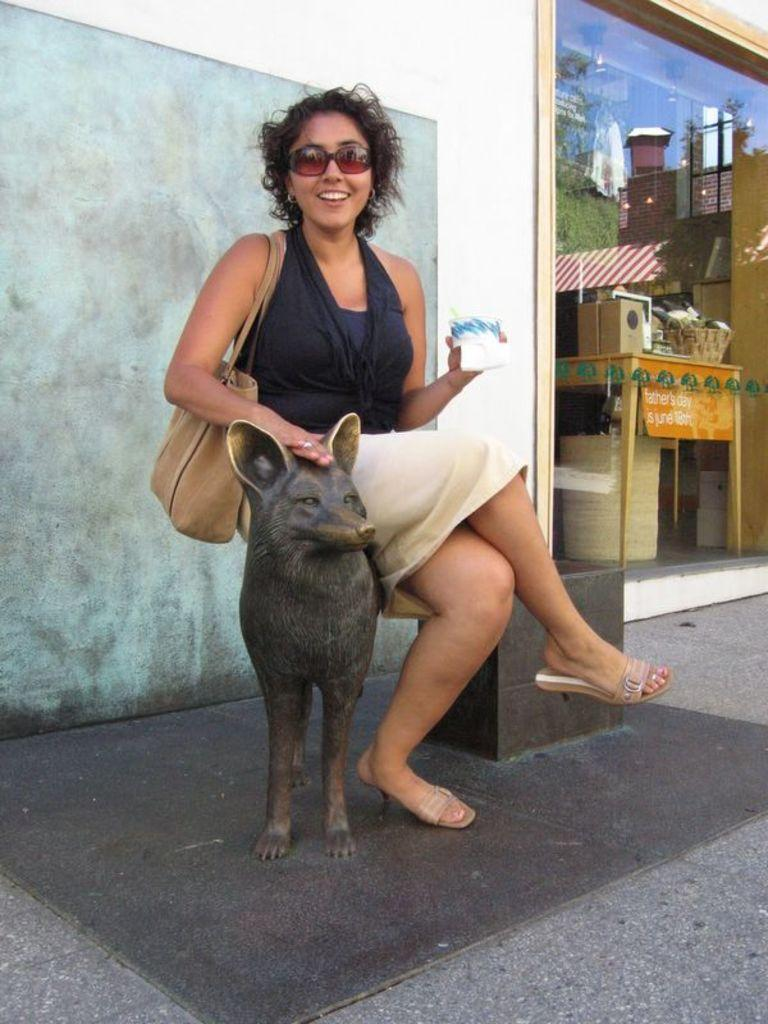Who is present in the image? There is a woman in the image. What is the woman doing in the image? The woman is seated on a dog statue. What is the woman wearing in the image? The woman is wearing a bag. What can be seen in the background of the image? There is a building and a glass door in the background of the image. What objects are on the table in the background of the image? There are objects on a table in the background of the image. What type of harmony is being played in the background of the image? There is no music or harmony present in the image; it is a still photograph of a woman seated on a dog statue. 